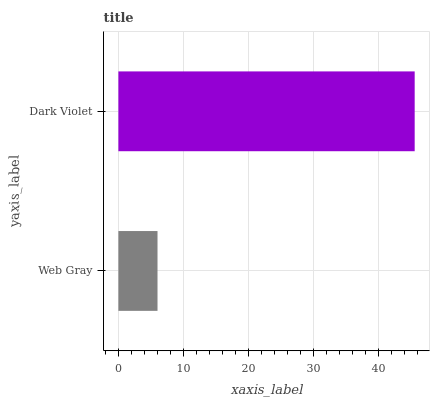Is Web Gray the minimum?
Answer yes or no. Yes. Is Dark Violet the maximum?
Answer yes or no. Yes. Is Dark Violet the minimum?
Answer yes or no. No. Is Dark Violet greater than Web Gray?
Answer yes or no. Yes. Is Web Gray less than Dark Violet?
Answer yes or no. Yes. Is Web Gray greater than Dark Violet?
Answer yes or no. No. Is Dark Violet less than Web Gray?
Answer yes or no. No. Is Dark Violet the high median?
Answer yes or no. Yes. Is Web Gray the low median?
Answer yes or no. Yes. Is Web Gray the high median?
Answer yes or no. No. Is Dark Violet the low median?
Answer yes or no. No. 